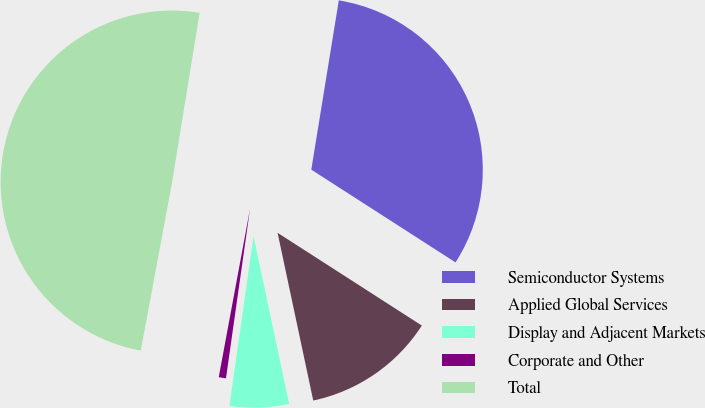Convert chart. <chart><loc_0><loc_0><loc_500><loc_500><pie_chart><fcel>Semiconductor Systems<fcel>Applied Global Services<fcel>Display and Adjacent Markets<fcel>Corporate and Other<fcel>Total<nl><fcel>31.53%<fcel>12.57%<fcel>5.58%<fcel>0.68%<fcel>49.64%<nl></chart> 